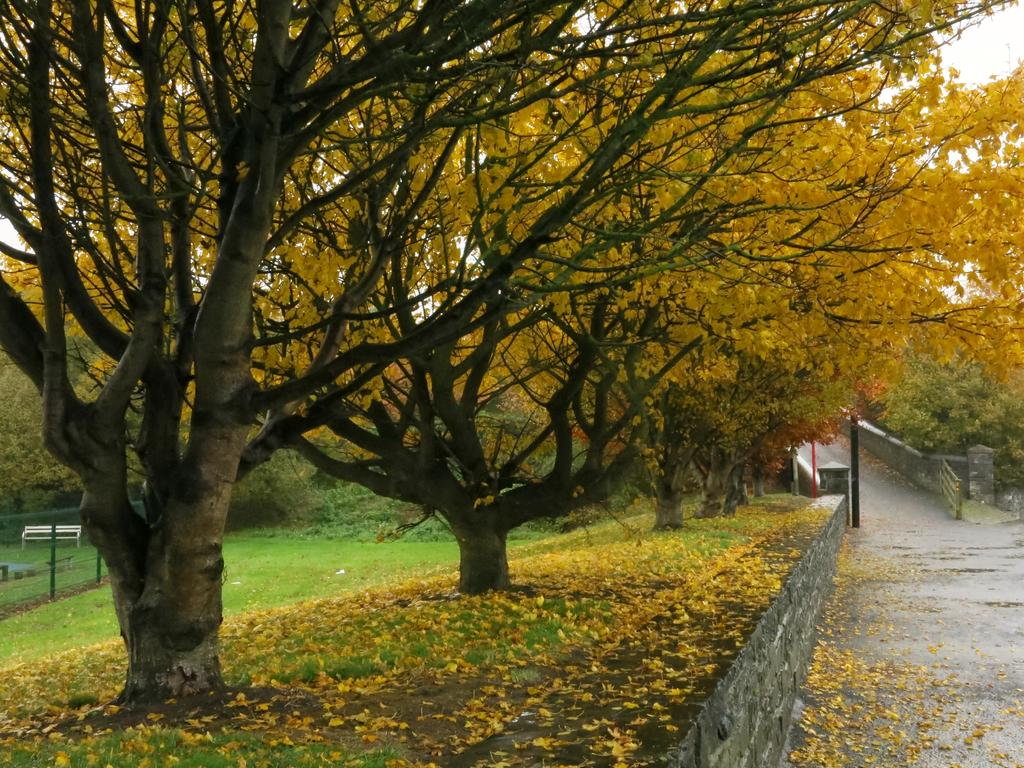What type of vegetation is present in the image? There are trees with flowers in the image. What type of seating is available in the image? There is a bench in the image. What type of ground cover is present in the image? There is grass in the image. What type of structure is present in the image? There is a pole in the image. What type of barrier is present on the road in the image? There is a metal object that looks like a gate on the road. What is visible in the background of the image? The sky is visible in the background of the image. Can you see a gun in the image? No, there is no gun present in the image. How many beads are hanging from the trees in the image? There are no beads present in the image; the trees have flowers. 